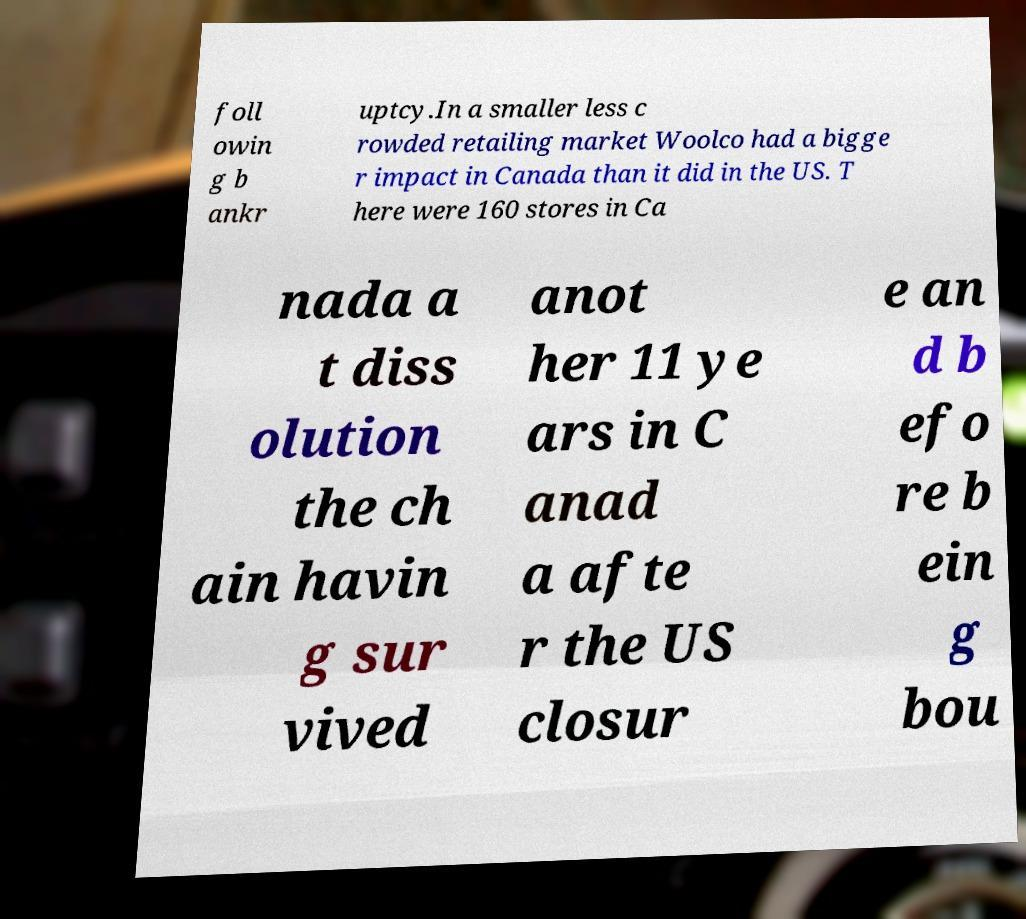For documentation purposes, I need the text within this image transcribed. Could you provide that? foll owin g b ankr uptcy.In a smaller less c rowded retailing market Woolco had a bigge r impact in Canada than it did in the US. T here were 160 stores in Ca nada a t diss olution the ch ain havin g sur vived anot her 11 ye ars in C anad a afte r the US closur e an d b efo re b ein g bou 